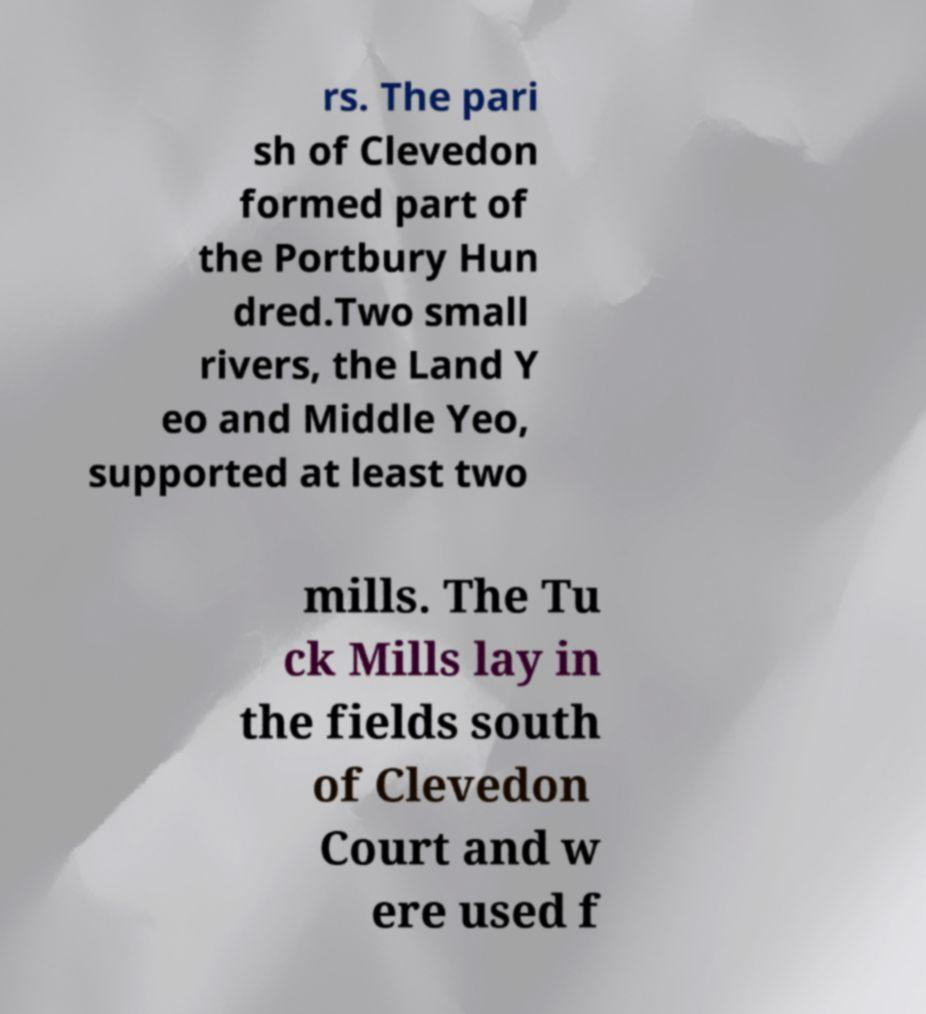Can you read and provide the text displayed in the image?This photo seems to have some interesting text. Can you extract and type it out for me? rs. The pari sh of Clevedon formed part of the Portbury Hun dred.Two small rivers, the Land Y eo and Middle Yeo, supported at least two mills. The Tu ck Mills lay in the fields south of Clevedon Court and w ere used f 